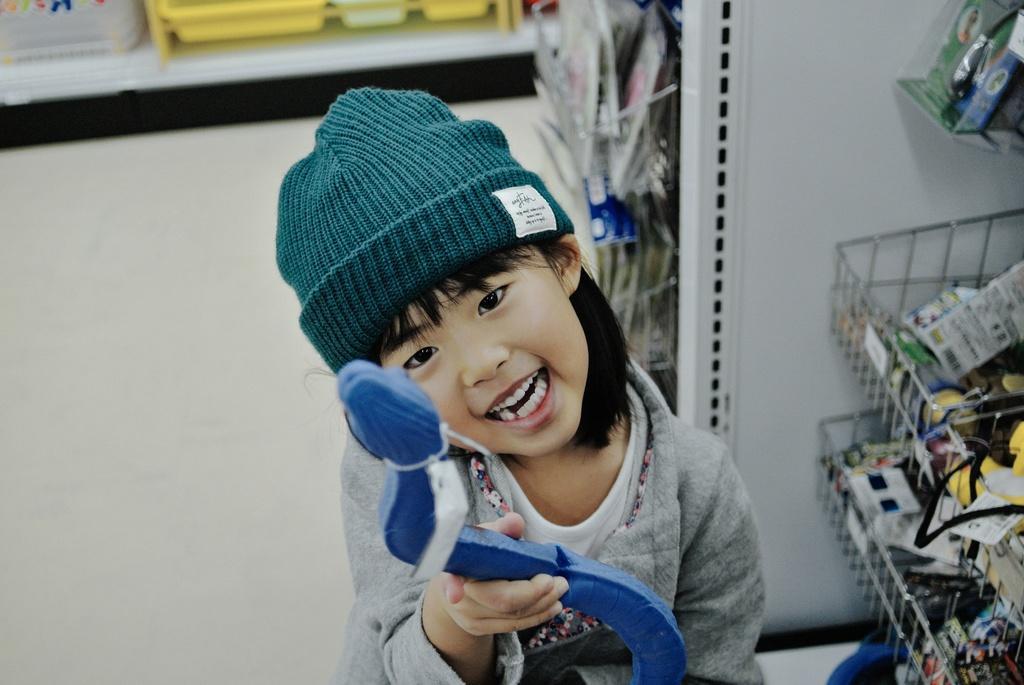How would you summarize this image in a sentence or two? In the image there is a kid with grey jacket, white t-shirt and a cap on the head. And the kid is holding something in the hand. On the right side of the image there are stands with few items in it. Beside that there is a white wall with few items in it. At the top of the image there are yellow and white color objects. 